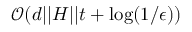Convert formula to latex. <formula><loc_0><loc_0><loc_500><loc_500>\mathcal { O } ( d | | H | | t + \log ( 1 / \epsilon ) )</formula> 